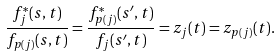Convert formula to latex. <formula><loc_0><loc_0><loc_500><loc_500>\frac { f _ { j } ^ { * } ( s , t ) } { f _ { p ( j ) } ( s , t ) } = \frac { f _ { p ( j ) } ^ { * } ( s ^ { \prime } , t ) } { f _ { j } ( s ^ { \prime } , t ) } = z _ { j } ( t ) = z _ { p ( j ) } ( t ) .</formula> 